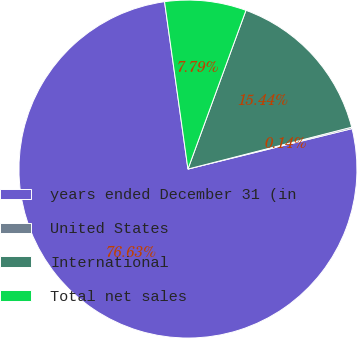Convert chart. <chart><loc_0><loc_0><loc_500><loc_500><pie_chart><fcel>years ended December 31 (in<fcel>United States<fcel>International<fcel>Total net sales<nl><fcel>76.64%<fcel>0.14%<fcel>15.44%<fcel>7.79%<nl></chart> 